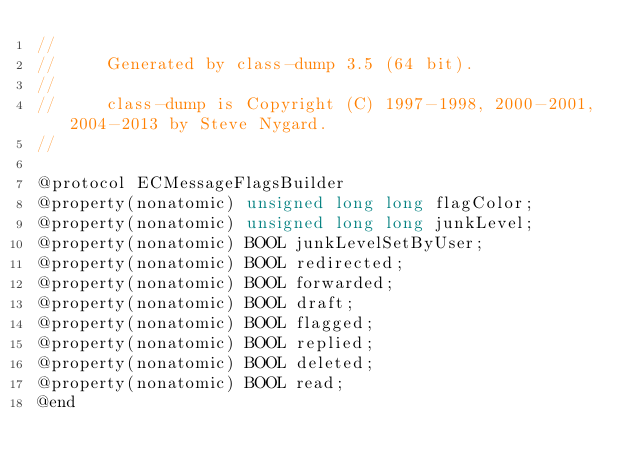Convert code to text. <code><loc_0><loc_0><loc_500><loc_500><_C_>//
//     Generated by class-dump 3.5 (64 bit).
//
//     class-dump is Copyright (C) 1997-1998, 2000-2001, 2004-2013 by Steve Nygard.
//

@protocol ECMessageFlagsBuilder
@property(nonatomic) unsigned long long flagColor;
@property(nonatomic) unsigned long long junkLevel;
@property(nonatomic) BOOL junkLevelSetByUser;
@property(nonatomic) BOOL redirected;
@property(nonatomic) BOOL forwarded;
@property(nonatomic) BOOL draft;
@property(nonatomic) BOOL flagged;
@property(nonatomic) BOOL replied;
@property(nonatomic) BOOL deleted;
@property(nonatomic) BOOL read;
@end

</code> 